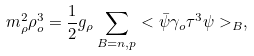<formula> <loc_0><loc_0><loc_500><loc_500>m ^ { 2 } _ { \rho } \rho ^ { 3 } _ { o } = \frac { 1 } { 2 } g _ { \rho } \sum _ { B = n , p } < \bar { \psi } \gamma _ { o } \tau ^ { 3 } \psi > _ { B } ,</formula> 